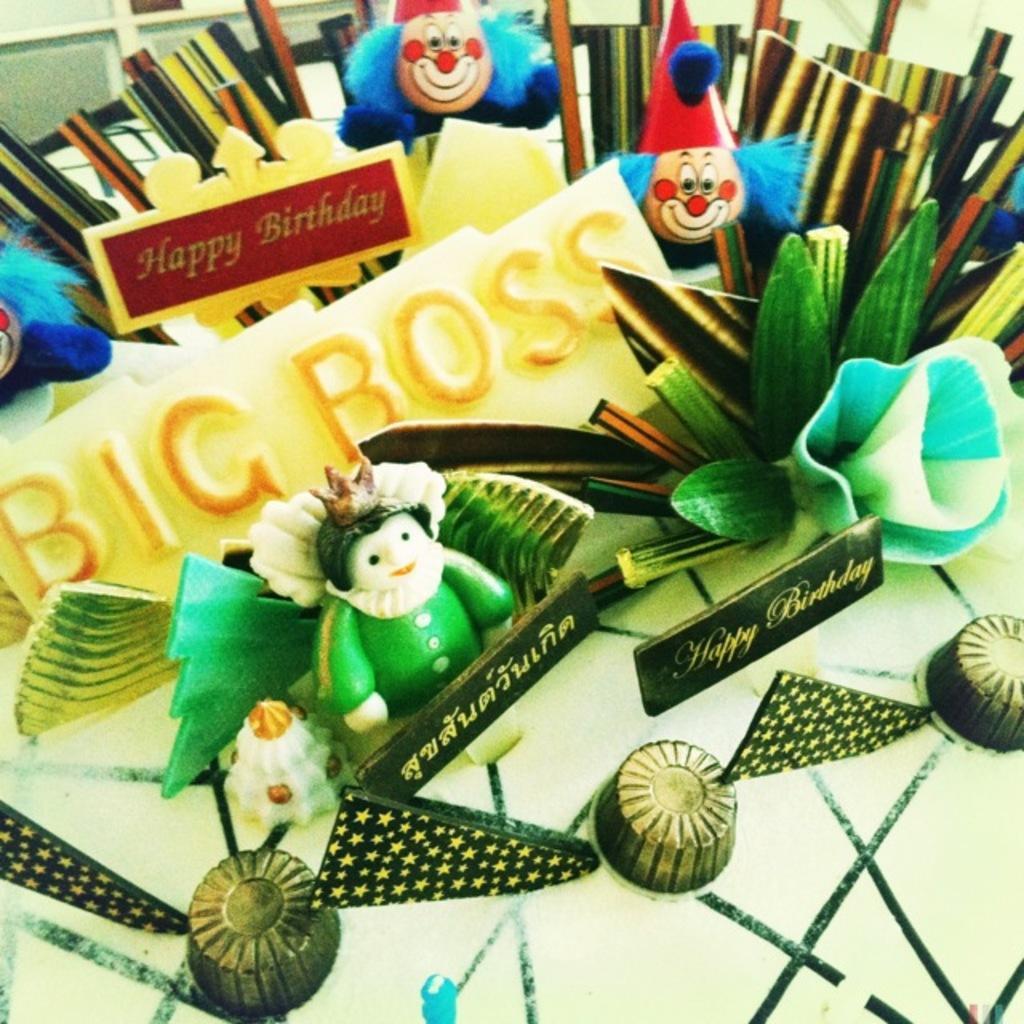Please provide a concise description of this image. In this image we can see some toys, name boards and other objects on the table. 